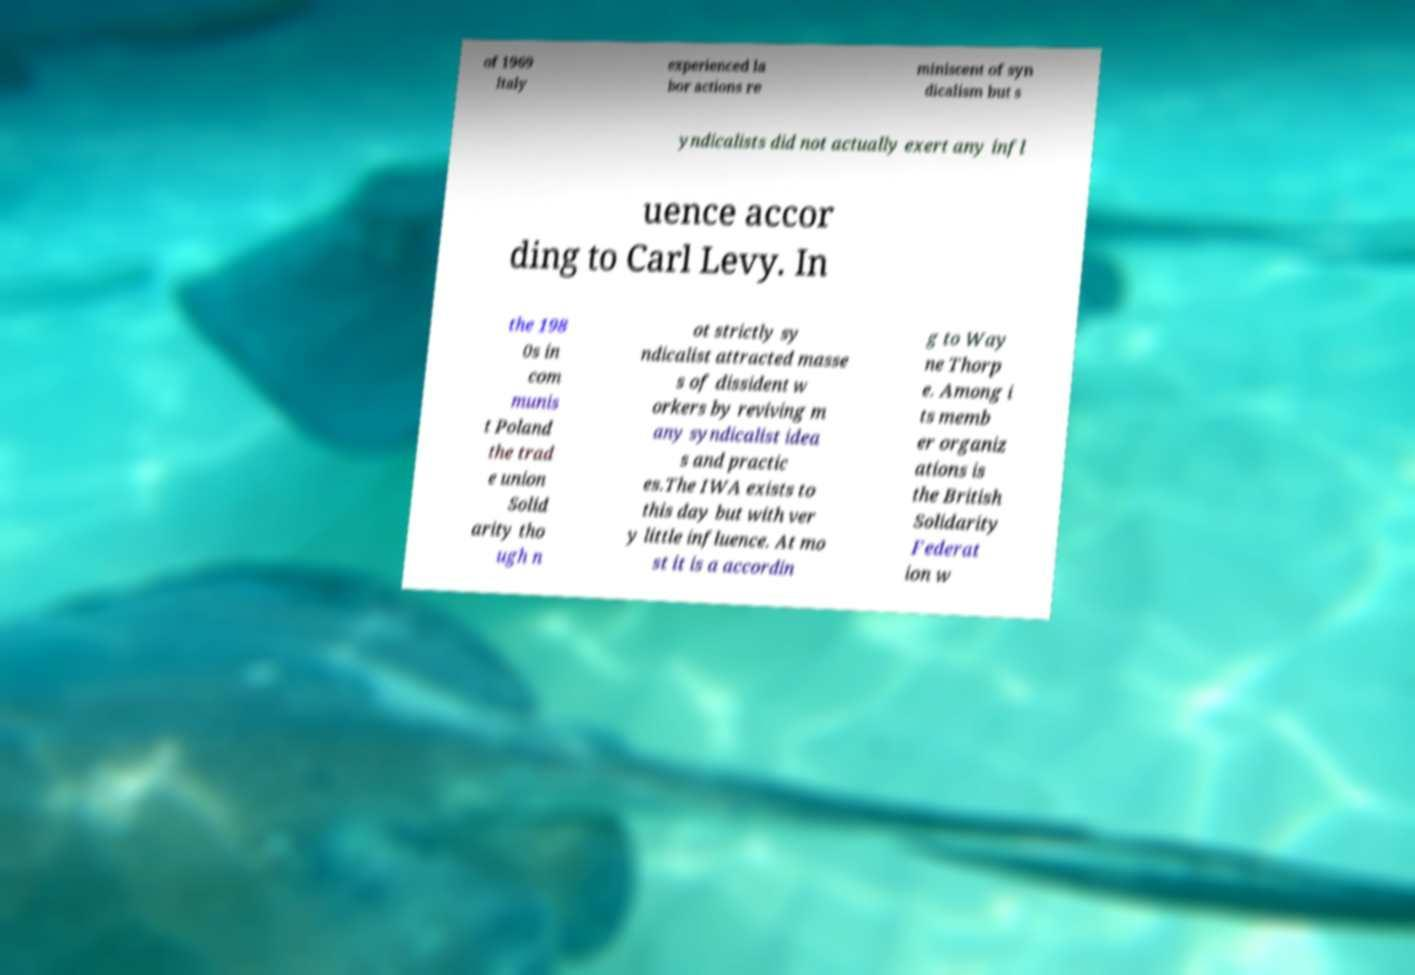For documentation purposes, I need the text within this image transcribed. Could you provide that? of 1969 Italy experienced la bor actions re miniscent of syn dicalism but s yndicalists did not actually exert any infl uence accor ding to Carl Levy. In the 198 0s in com munis t Poland the trad e union Solid arity tho ugh n ot strictly sy ndicalist attracted masse s of dissident w orkers by reviving m any syndicalist idea s and practic es.The IWA exists to this day but with ver y little influence. At mo st it is a accordin g to Way ne Thorp e. Among i ts memb er organiz ations is the British Solidarity Federat ion w 